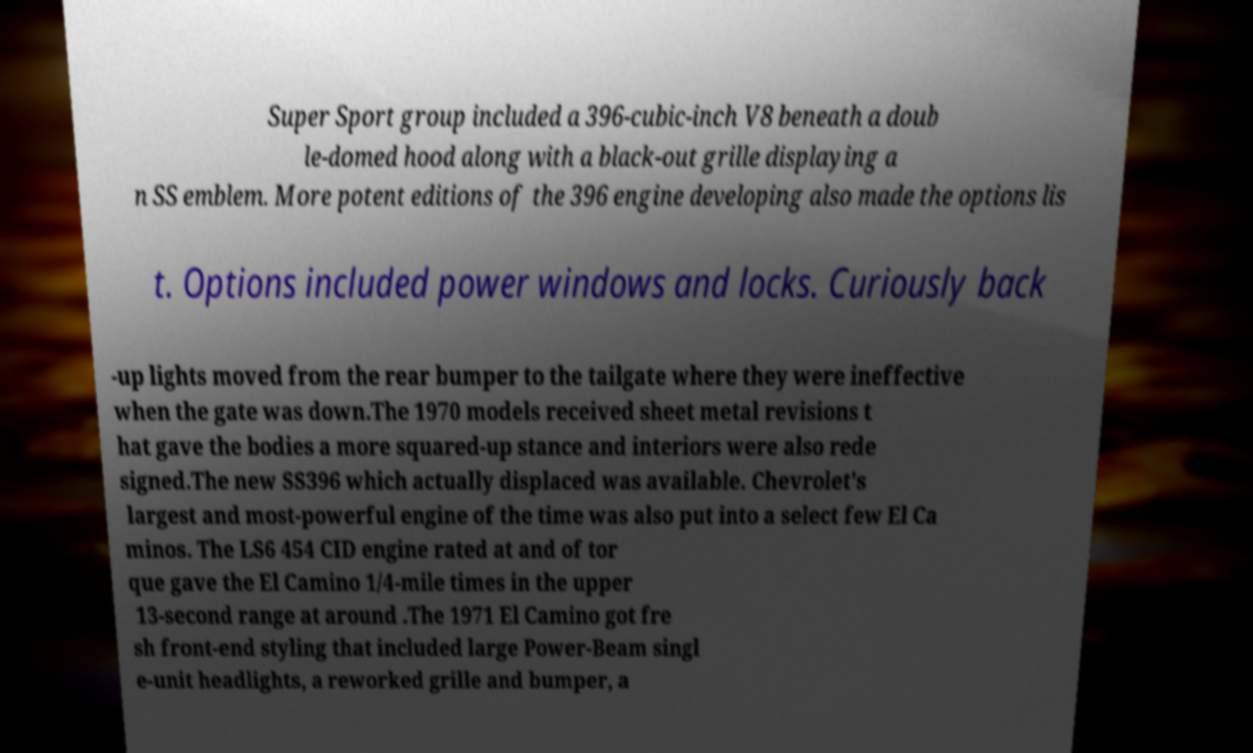Can you accurately transcribe the text from the provided image for me? Super Sport group included a 396-cubic-inch V8 beneath a doub le-domed hood along with a black-out grille displaying a n SS emblem. More potent editions of the 396 engine developing also made the options lis t. Options included power windows and locks. Curiously back -up lights moved from the rear bumper to the tailgate where they were ineffective when the gate was down.The 1970 models received sheet metal revisions t hat gave the bodies a more squared-up stance and interiors were also rede signed.The new SS396 which actually displaced was available. Chevrolet's largest and most-powerful engine of the time was also put into a select few El Ca minos. The LS6 454 CID engine rated at and of tor que gave the El Camino 1/4-mile times in the upper 13-second range at around .The 1971 El Camino got fre sh front-end styling that included large Power-Beam singl e-unit headlights, a reworked grille and bumper, a 